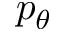<formula> <loc_0><loc_0><loc_500><loc_500>p _ { \theta }</formula> 